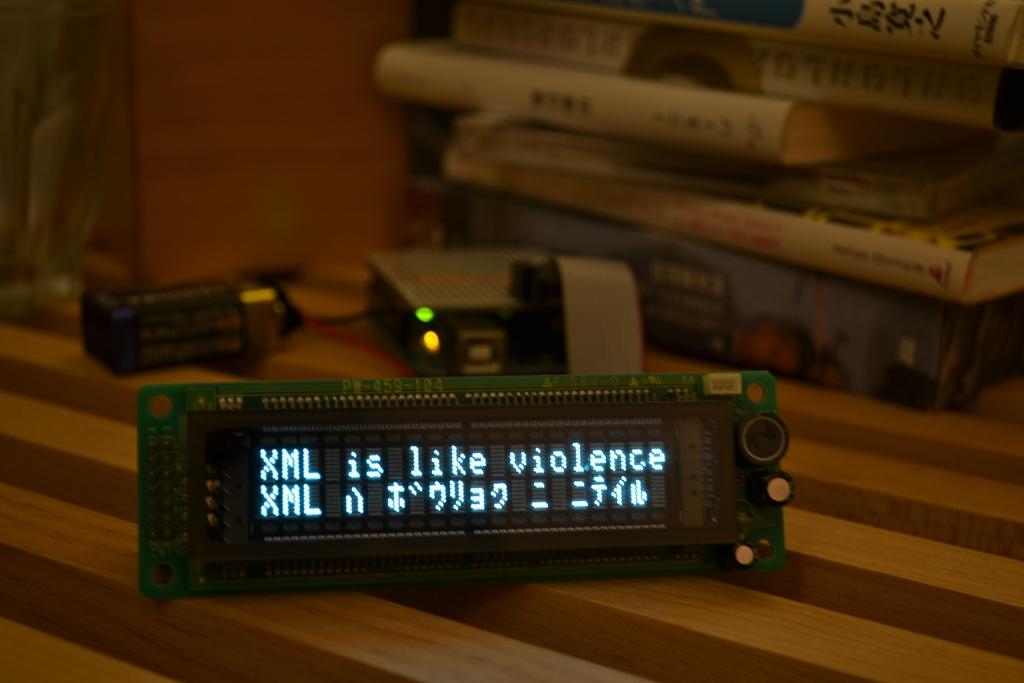<image>
Write a terse but informative summary of the picture. A digital display says XML is like violence. 